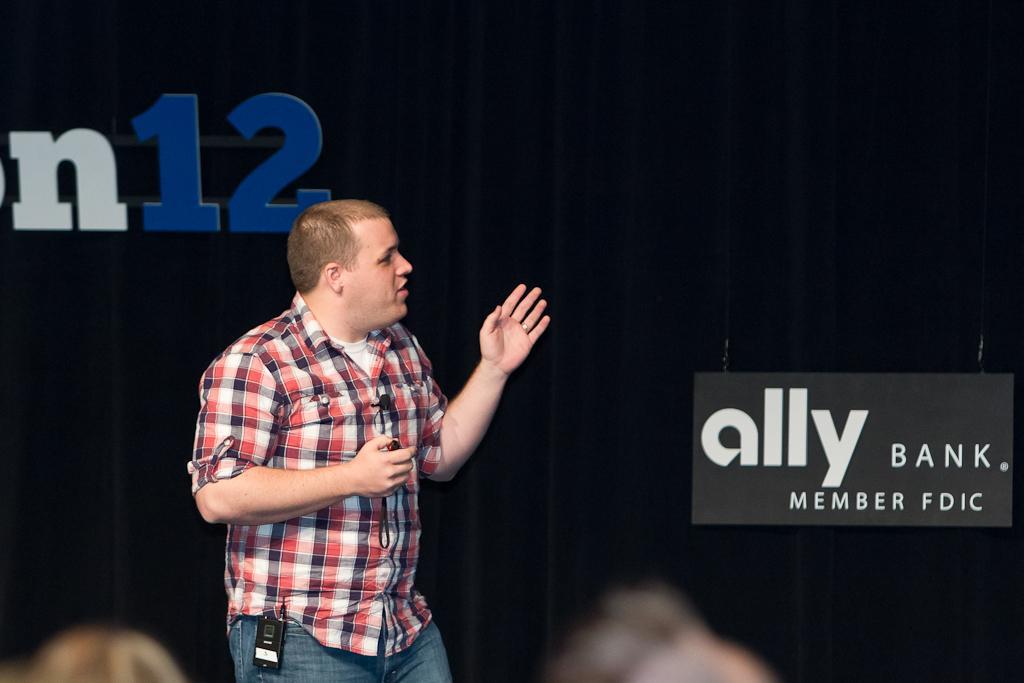Could you give a brief overview of what you see in this image? In this picture we can see a man is explaining something. Behind the man, there are boards and a curtain. At the bottom of the image, there are two blurred objects. 